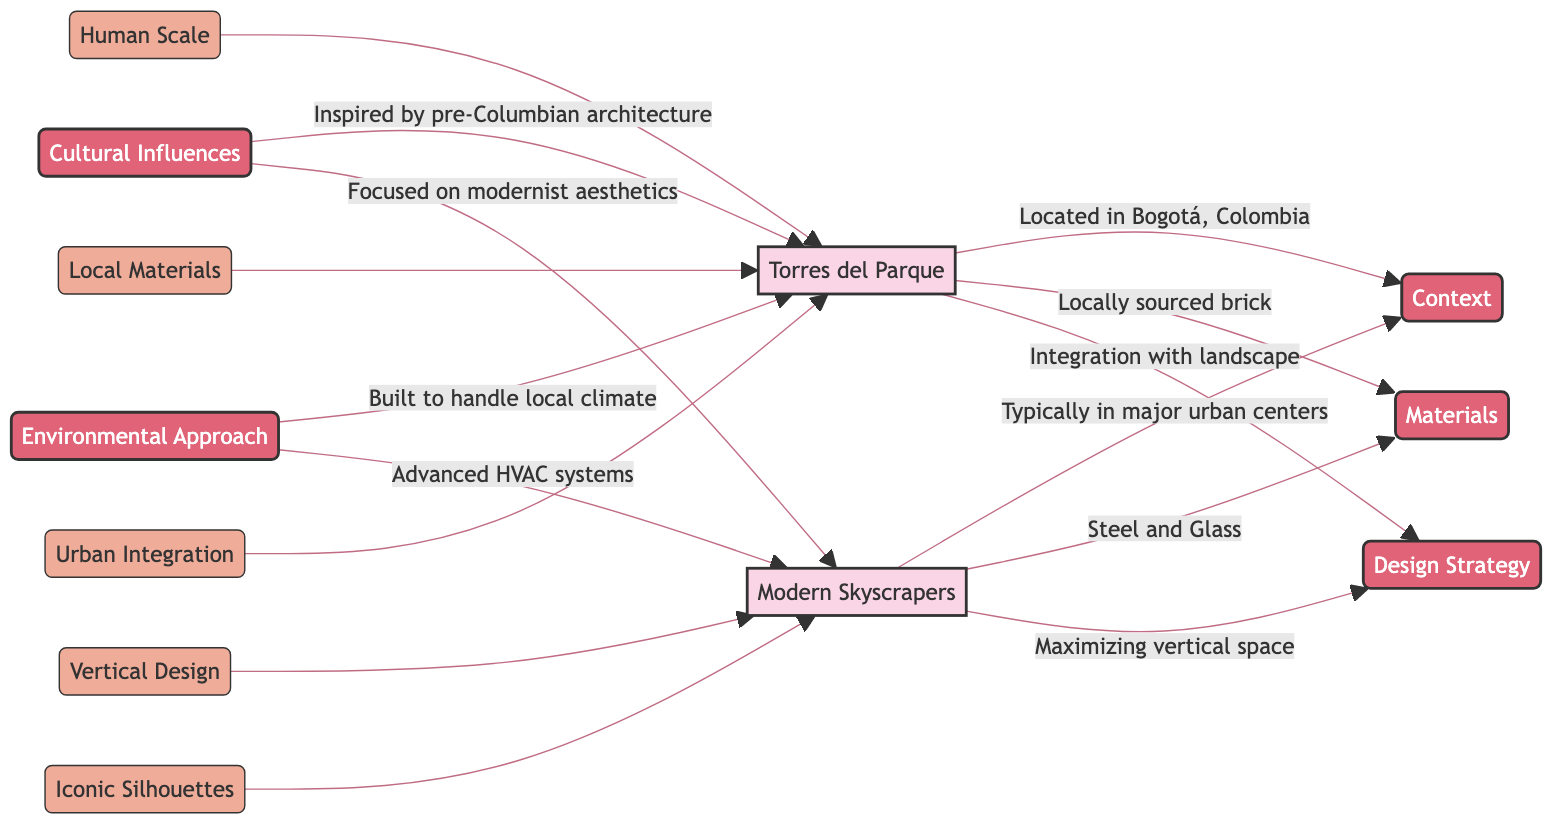What is the main context of Torres del Parque? The diagram states that Torres del Parque is located in Bogotá, Colombia, which describes its geographical context.
Answer: Bogotá, Colombia What materials are used in Modern Skyscrapers? According to the diagram, Modern Skyscrapers are primarily constructed using steel and glass as their main materials.
Answer: Steel and Glass How many cultural influences are listed for Torres del Parque? The diagram indicates that Torres del Parque is inspired by pre-Columbian architecture, which highlights its cultural influence. There is only one listed influence here.
Answer: 1 What design strategy characterizes Modern Skyscrapers? The diagram indicates that Modern Skyscrapers utilize the strategy of maximizing vertical space, which defines their design approach.
Answer: Maximizing vertical space Which architectural element is associated with Torres del Parque in terms of human scale? The diagram relates Torres del Parque directly to the concept of human scale, emphasizing its better fit within human experience.
Answer: Human Scale What is the environmental approach of Torres del Parque? According to the diagram, the environmental approach for Torres del Parque involves being built to handle the local climate, highlighting its adaptability to surroundings.
Answer: Built to handle local climate What design strategy is Torres del Parque known for? The diagram notes that Torres del Parque employs an integration with the landscape as its design strategy, showcasing its harmony with nature.
Answer: Integration with landscape Which architectural feature is Modern Skyscrapers known for? The diagram indicates that Modern Skyscrapers often boast iconic silhouettes as a key architectural feature, signifying their prominence in the skyline.
Answer: Iconic Silhouettes How do the cultural influences differ between Torres del Parque and Modern Skyscrapers? The diagram shows that Torres del Parque is influenced by pre-Columbian architecture, while Modern Skyscrapers focus on modernist aesthetics. This shows a fundamental difference in their cultural grounding.
Answer: Different cultural influences What approach do Modern Skyscrapers take towards environmental considerations? The diagram states that Modern Skyscrapers utilize advanced HVAC systems to manage environmental concerns, illustrating a modern technological approach.
Answer: Advanced HVAC systems 